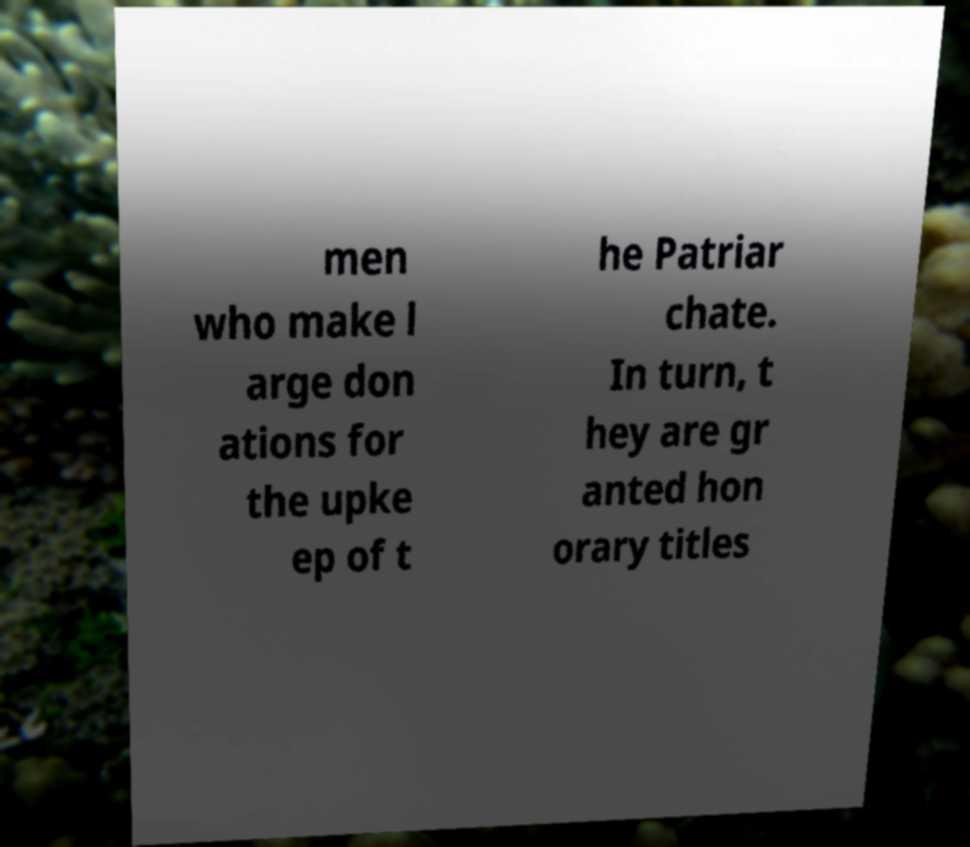Can you accurately transcribe the text from the provided image for me? men who make l arge don ations for the upke ep of t he Patriar chate. In turn, t hey are gr anted hon orary titles 